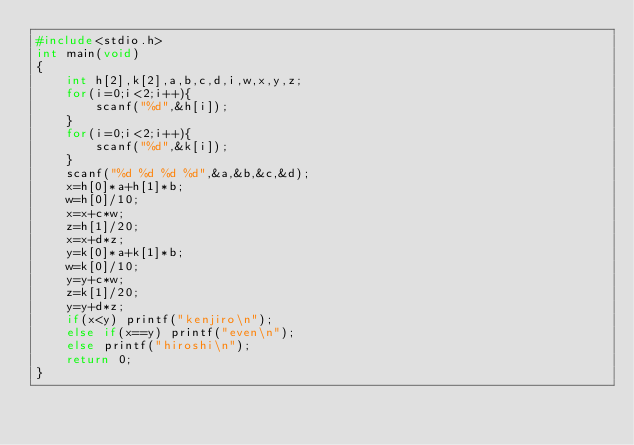Convert code to text. <code><loc_0><loc_0><loc_500><loc_500><_C_>#include<stdio.h>
int main(void)
{
	int h[2],k[2],a,b,c,d,i,w,x,y,z;
	for(i=0;i<2;i++){
		scanf("%d",&h[i]);
	}
	for(i=0;i<2;i++){
		scanf("%d",&k[i]);
	}
	scanf("%d %d %d %d",&a,&b,&c,&d);
	x=h[0]*a+h[1]*b;
	w=h[0]/10;
	x=x+c*w;
	z=h[1]/20;
	x=x+d*z;
	y=k[0]*a+k[1]*b;
	w=k[0]/10;
	y=y+c*w;
	z=k[1]/20;
	y=y+d*z;
	if(x<y) printf("kenjiro\n");
	else if(x==y) printf("even\n");
	else printf("hiroshi\n");
	return 0;
}
	
</code> 